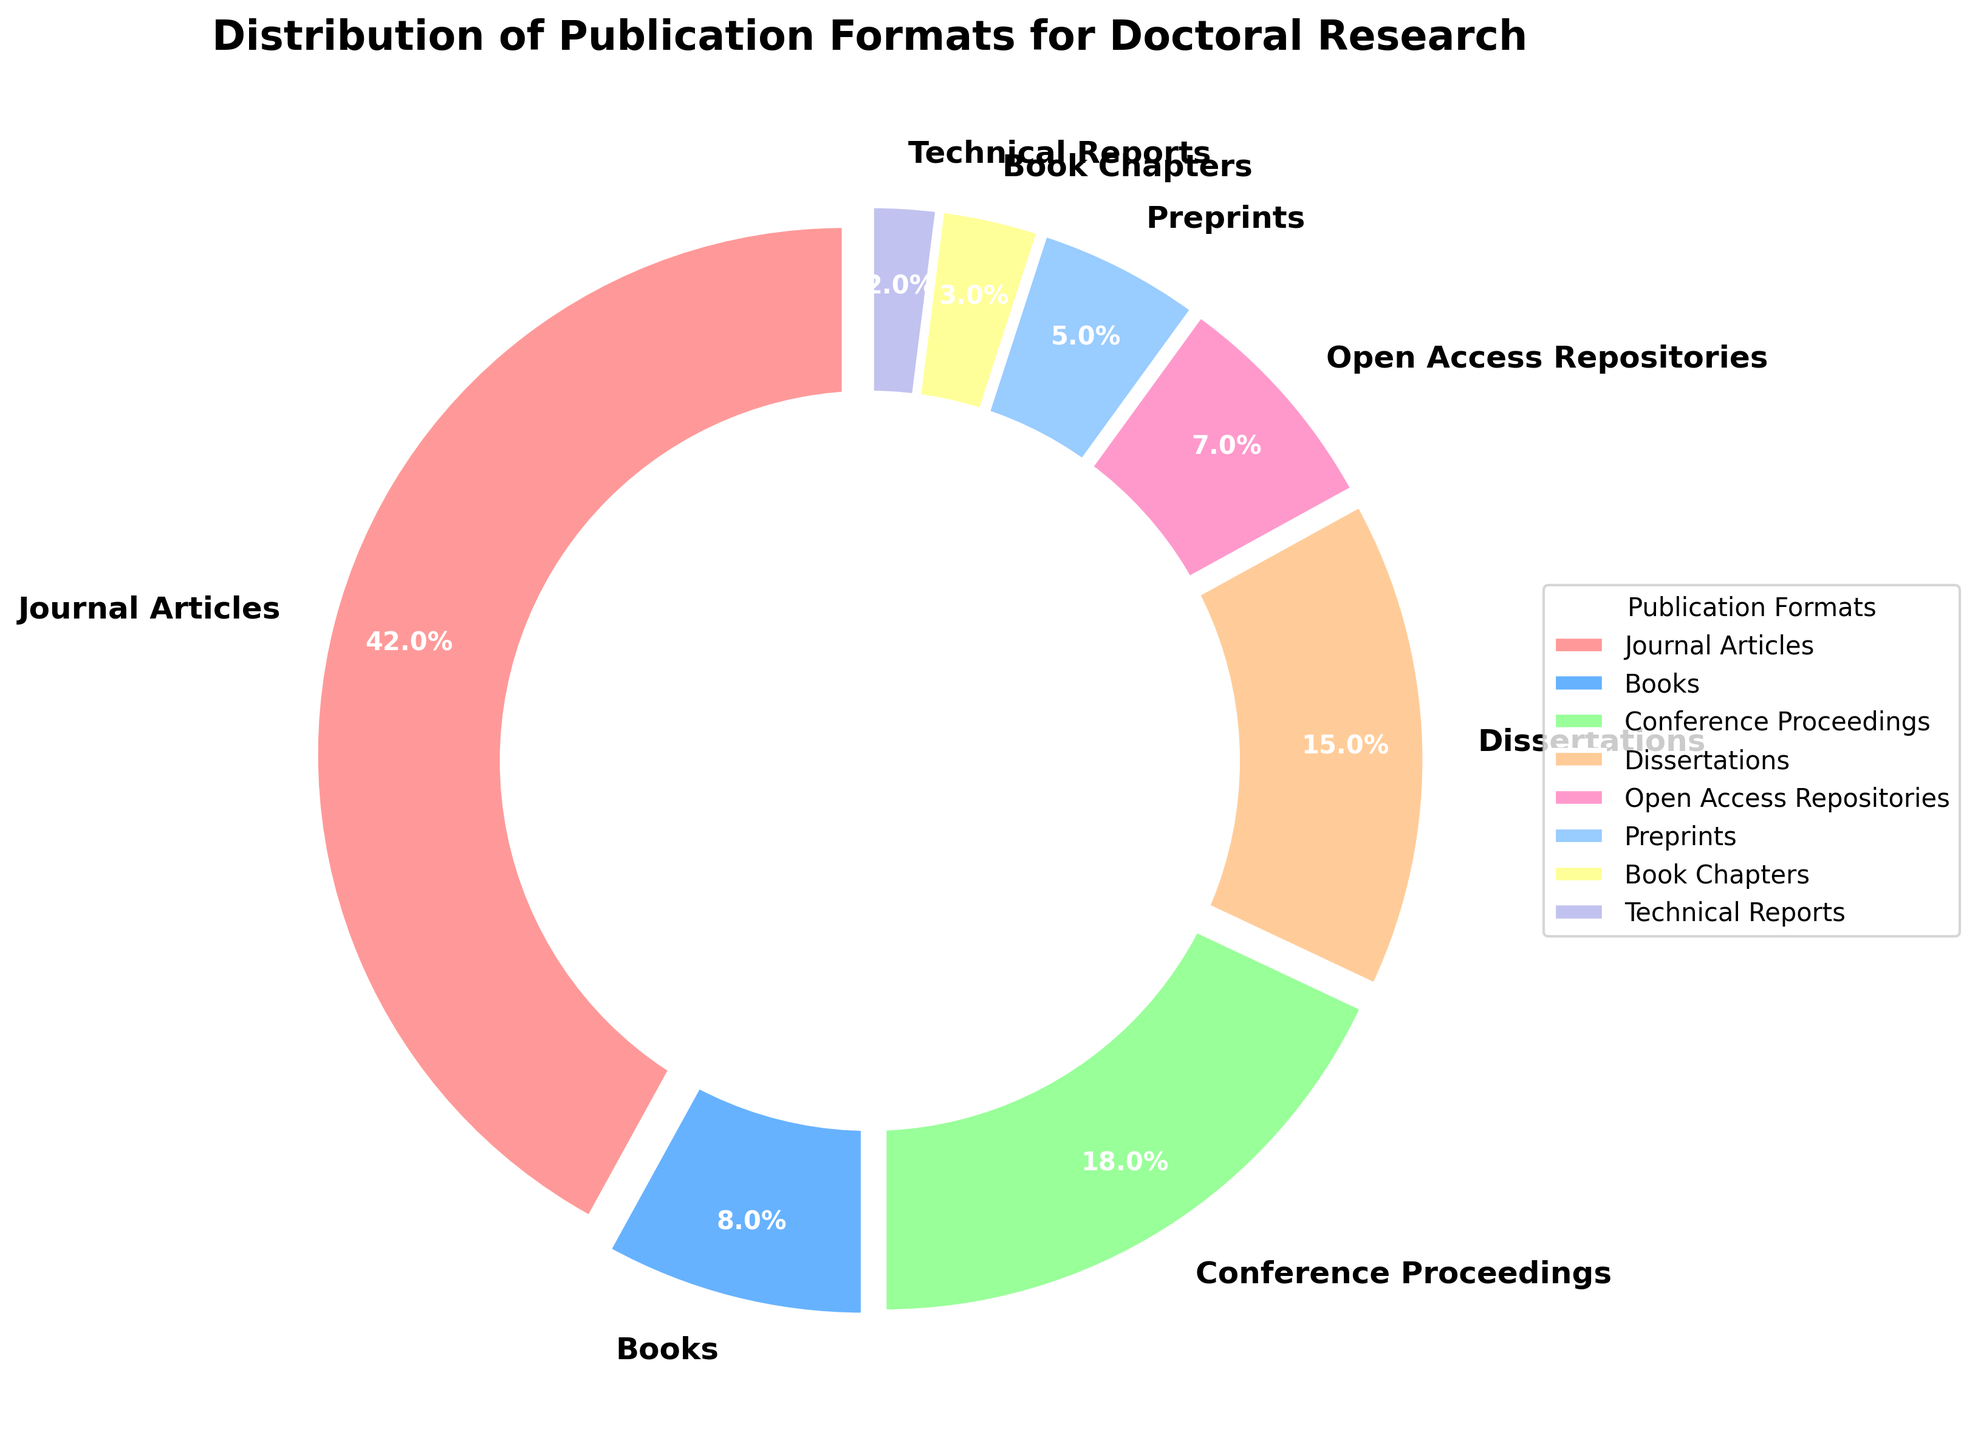Which publication format has the highest percentage? The figure shows a pie chart with the distribution of publication formats. The segment labeled "Journal Articles" has the largest slice, which is 42%.
Answer: Journal Articles What is the combined percentage of Dissertations and Preprints? The figure shows that the percentage for Dissertations is 15% and for Preprints is 5%. Adding these together gives 15% + 5% = 20%.
Answer: 20% Are there more publications in Books or in Open Access Repositories? From the pie chart, Books are labeled with 8% and Open Access Repositories with 7%. Since 8% is greater than 7%, there are more publications in Books.
Answer: Books Which publication formats have a percentage less than 10%? The figure shows the percentages for each format. The formats with less than 10% are Books (8%), Open Access Repositories (7%), Preprints (5%), Book Chapters (3%), and Technical Reports (2%).
Answer: Books, Open Access Repositories, Preprints, Book Chapters, Technical Reports What is the difference in percentage between Journal Articles and Conference Proceedings? The figure shows that Journal Articles have 42% and Conference Proceedings have 18%. The difference is calculated as 42% - 18% = 24%.
Answer: 24% Rank the publication formats from highest to lowest percentage. By observing the figure, the percentages from highest to lowest are: Journal Articles (42%), Conference Proceedings (18%), Dissertations (15%), Books (8%), Open Access Repositories (7%), Preprints (5%), Book Chapters (3%), Technical Reports (2%).
Answer: Journal Articles, Conference Proceedings, Dissertations, Books, Open Access Repositories, Preprints, Book Chapters, Technical Reports What percentage of publications are neither Journal Articles nor Conference Proceedings? The percentages for Journal Articles and Conference Proceedings are 42% and 18%, respectively. Summing these gives 42% + 18% = 60%. Subtracting from 100% (total) gives 100% - 60% = 40%.
Answer: 40% Which publications have a percentage of below 5%? By looking at the figure, Book Chapters have 3% and Technical Reports have 2%, both of which are below 5%.
Answer: Book Chapters and Technical Reports What is the average percentage of all publication formats? There are 8 publication formats with percentages: 42%, 8%, 18%, 15%, 7%, 5%, 3%, and 2%. Summing these gives a total of 100%. The average is calculated as 100% / 8 = 12.5%.
Answer: 12.5% 